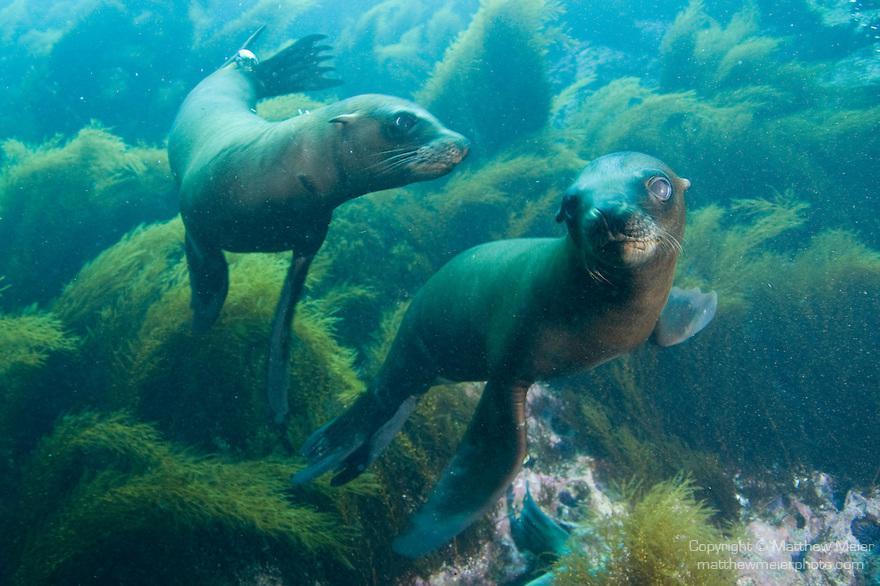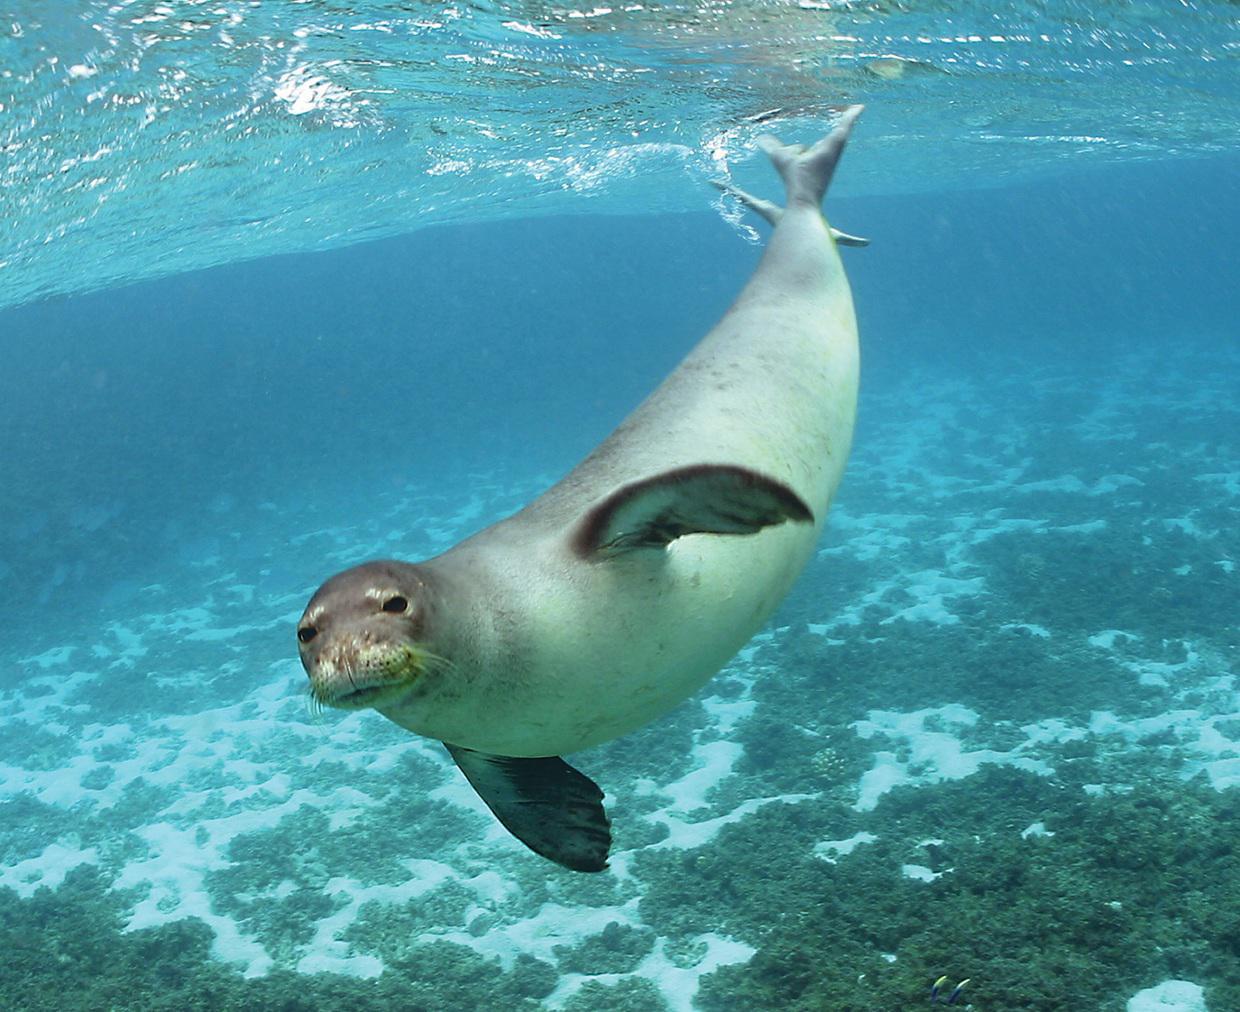The first image is the image on the left, the second image is the image on the right. Analyze the images presented: Is the assertion "The right image image contains exactly one seal." valid? Answer yes or no. Yes. The first image is the image on the left, the second image is the image on the right. Considering the images on both sides, is "There are more than ten sea lions in the images." valid? Answer yes or no. No. 